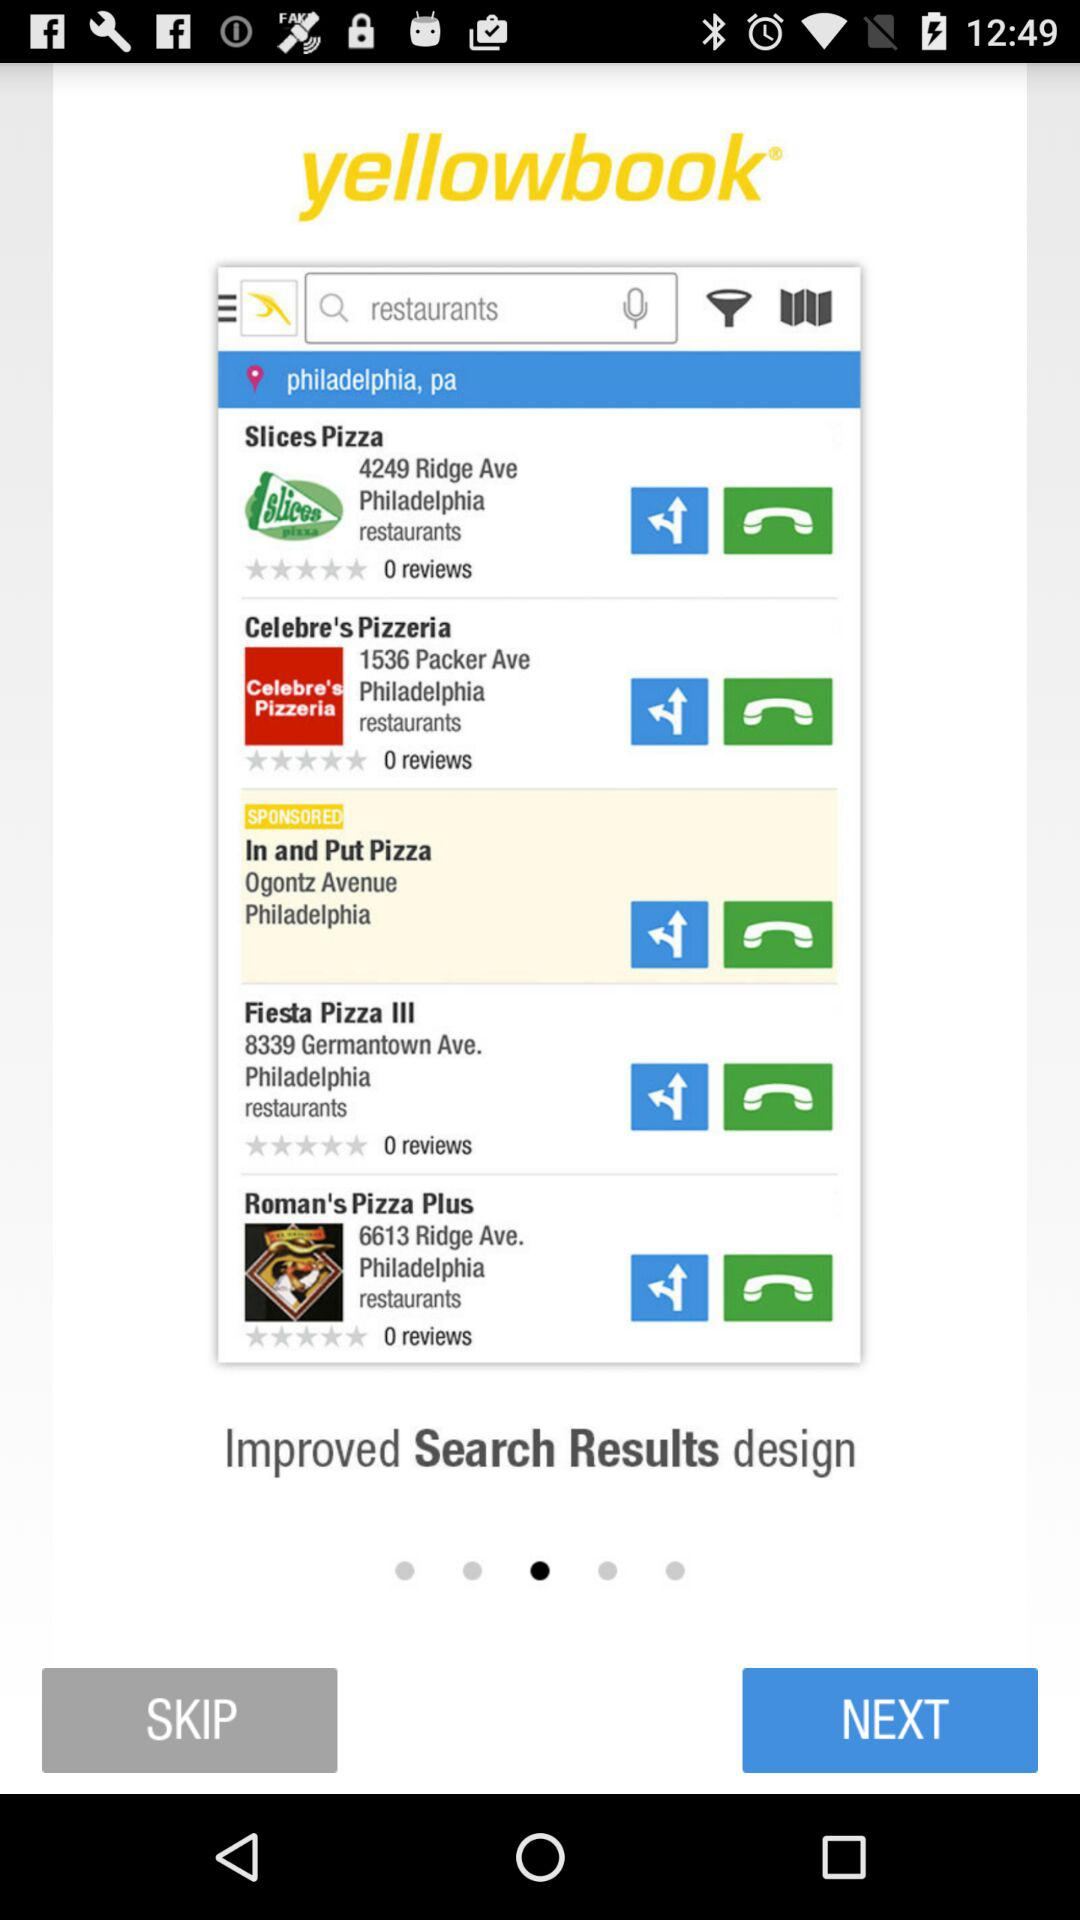What location is displayed? The displayed location is Philadelphia, Pa. 